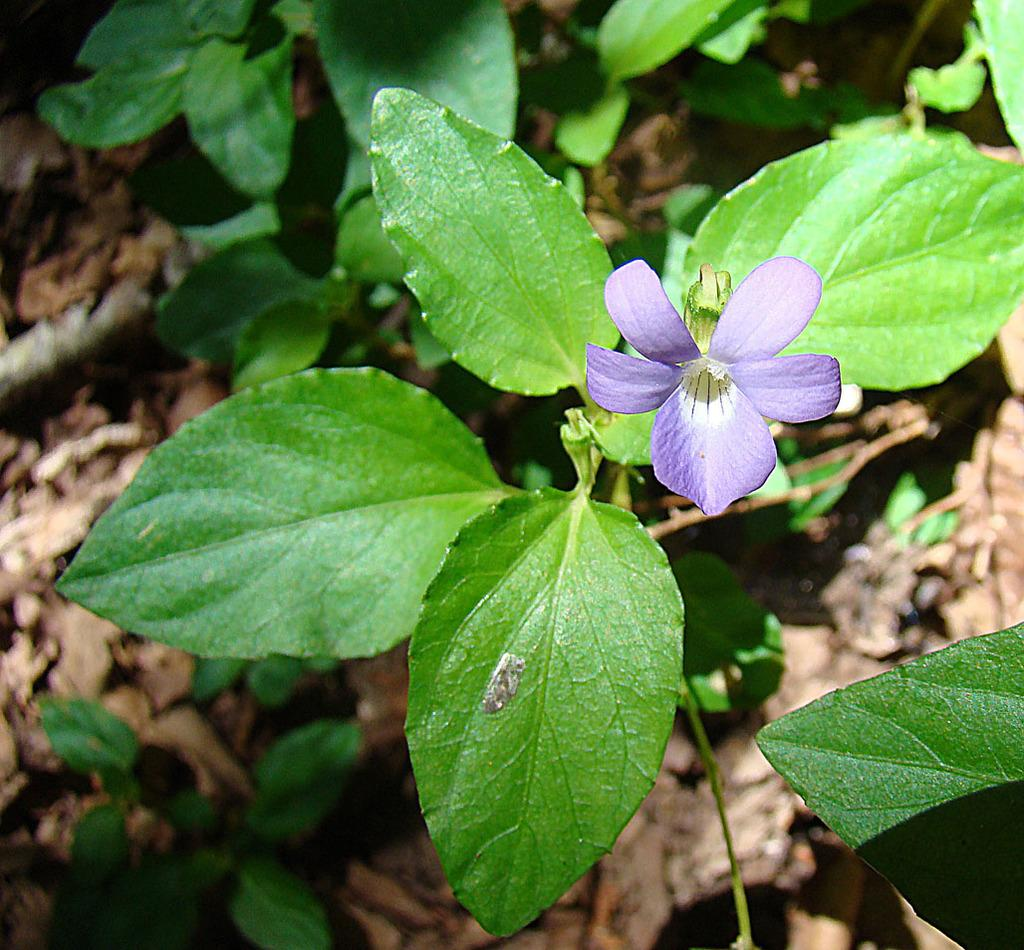What color are the flowers on the plant in the image? The flowers on the plant are violet in color. What can be seen in the background of the image? The background of the image includes plants. How is the background of the image depicted? The background is blurred. What territory does the brother claim with his hammer in the image? There is no territory, brother, or hammer present in the image. 